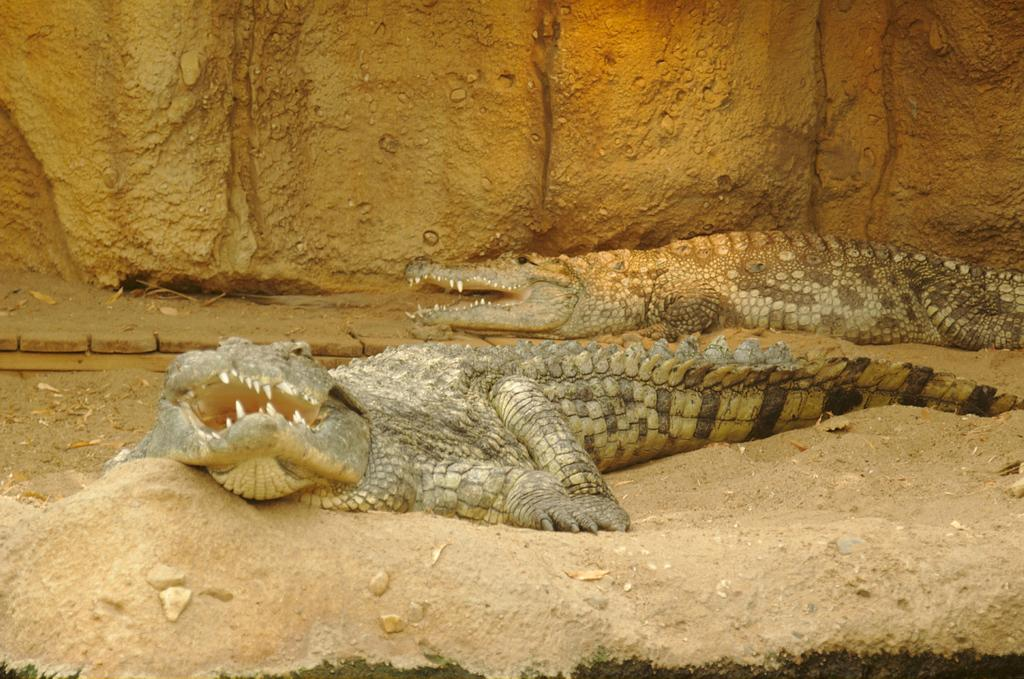What type of animals are in the image? There are crocodiles in the image. Where are the crocodiles located? The crocodiles are on the sand. What can be seen in the background of the image? There is a rock in the background of the image. What caption is written on the image? There is no caption present in the image. What type of bait is being used to attract the crocodiles in the image? There is no bait present in the image; the crocodiles are simply on the sand. 